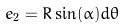<formula> <loc_0><loc_0><loc_500><loc_500>e _ { 2 } = R \sin ( \alpha ) d \theta</formula> 